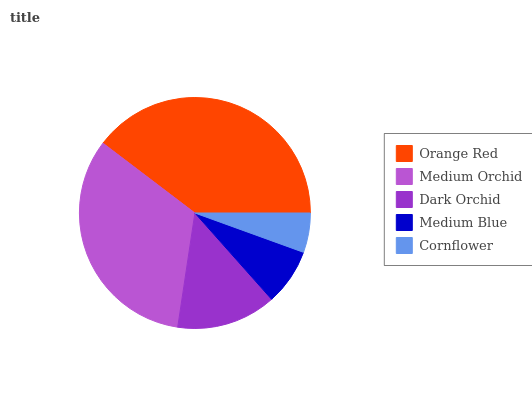Is Cornflower the minimum?
Answer yes or no. Yes. Is Orange Red the maximum?
Answer yes or no. Yes. Is Medium Orchid the minimum?
Answer yes or no. No. Is Medium Orchid the maximum?
Answer yes or no. No. Is Orange Red greater than Medium Orchid?
Answer yes or no. Yes. Is Medium Orchid less than Orange Red?
Answer yes or no. Yes. Is Medium Orchid greater than Orange Red?
Answer yes or no. No. Is Orange Red less than Medium Orchid?
Answer yes or no. No. Is Dark Orchid the high median?
Answer yes or no. Yes. Is Dark Orchid the low median?
Answer yes or no. Yes. Is Medium Orchid the high median?
Answer yes or no. No. Is Medium Blue the low median?
Answer yes or no. No. 